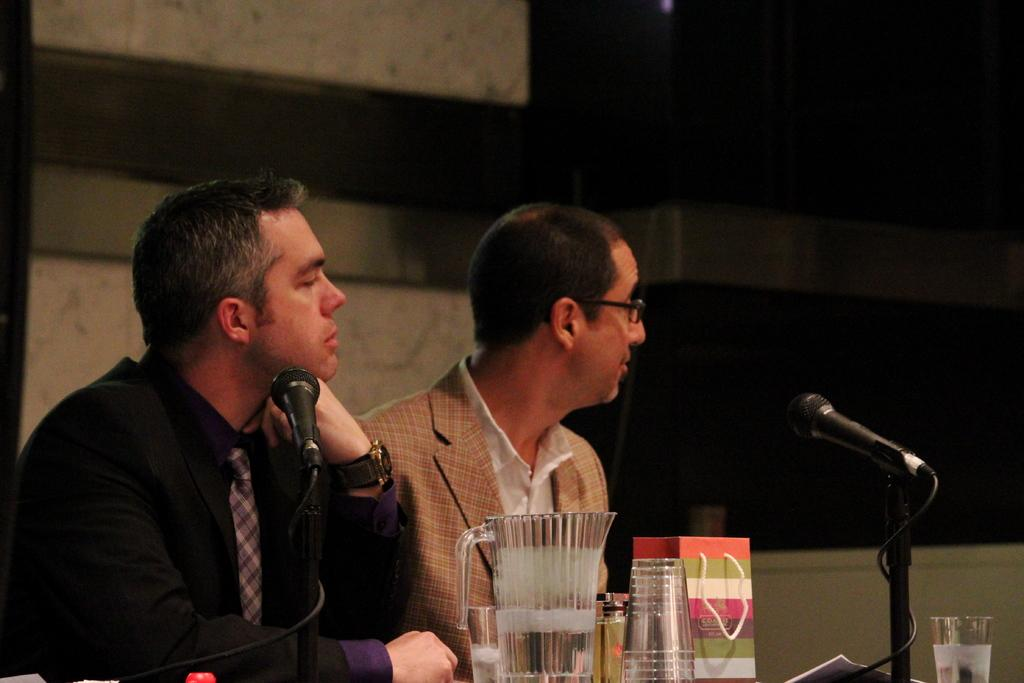What type of animals can be seen in the image? There are mice in the image. What objects are present in the image? There are glasses in the image. How many people are sitting in the image? There are two persons sitting in the image. What is the background element in the image? There is a wall in the image. What is the man on the left side wearing? The man sitting on the left side is wearing a black color jacket. What type of cloth is the man on the right side using to cover his head in the image? There is no cloth or head covering visible on the man on the right side in the image. Is the woman wearing a scarf in the image? There is no woman present in the image, only two men. What color is the umbrella that the mice are holding in the image? There are no umbrellas present in the image; the main subjects are mice and glasses. 